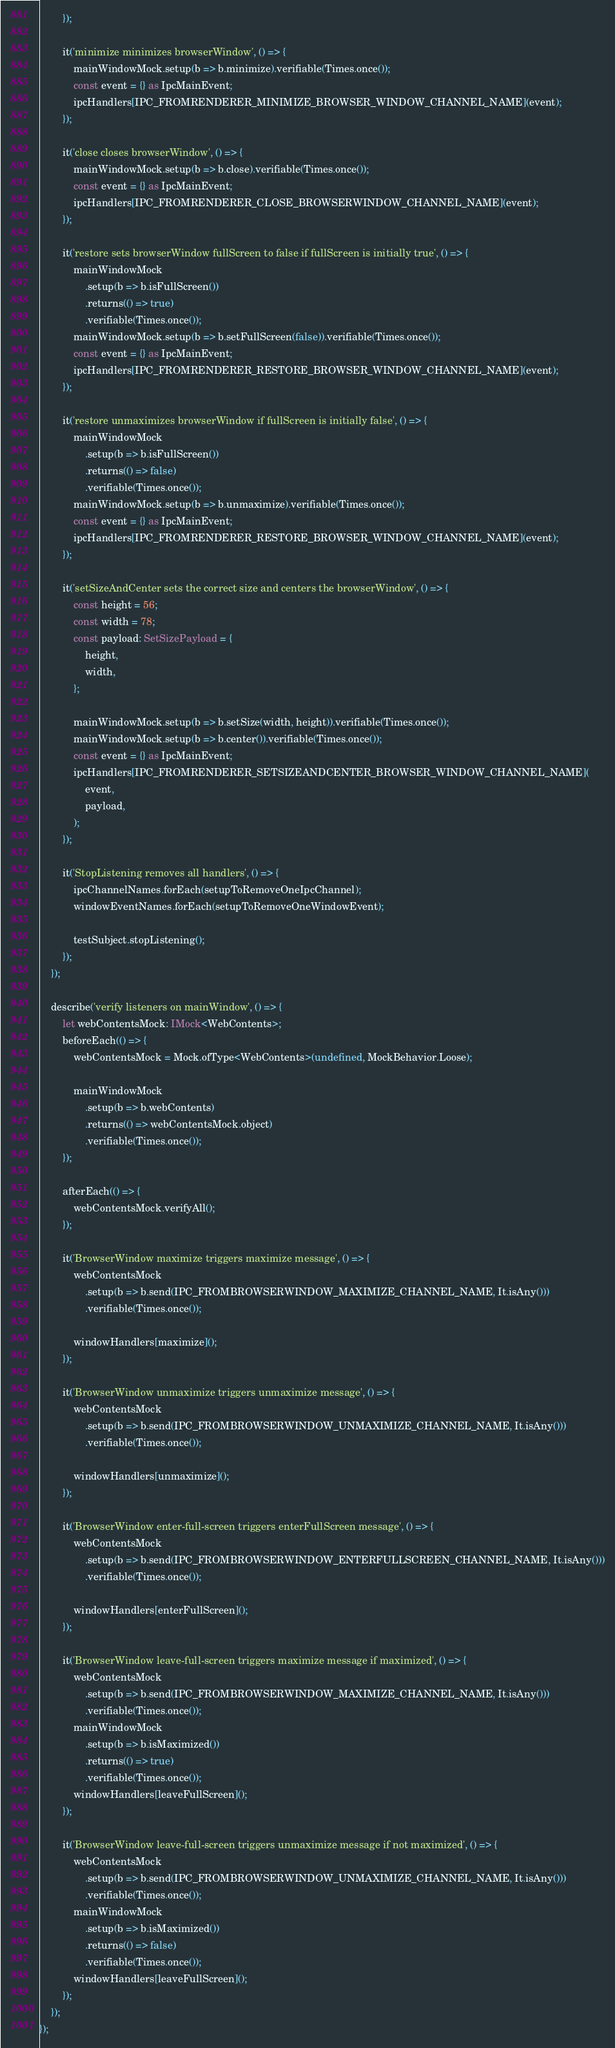Convert code to text. <code><loc_0><loc_0><loc_500><loc_500><_TypeScript_>        });

        it('minimize minimizes browserWindow', () => {
            mainWindowMock.setup(b => b.minimize).verifiable(Times.once());
            const event = {} as IpcMainEvent;
            ipcHandlers[IPC_FROMRENDERER_MINIMIZE_BROWSER_WINDOW_CHANNEL_NAME](event);
        });

        it('close closes browserWindow', () => {
            mainWindowMock.setup(b => b.close).verifiable(Times.once());
            const event = {} as IpcMainEvent;
            ipcHandlers[IPC_FROMRENDERER_CLOSE_BROWSERWINDOW_CHANNEL_NAME](event);
        });

        it('restore sets browserWindow fullScreen to false if fullScreen is initially true', () => {
            mainWindowMock
                .setup(b => b.isFullScreen())
                .returns(() => true)
                .verifiable(Times.once());
            mainWindowMock.setup(b => b.setFullScreen(false)).verifiable(Times.once());
            const event = {} as IpcMainEvent;
            ipcHandlers[IPC_FROMRENDERER_RESTORE_BROWSER_WINDOW_CHANNEL_NAME](event);
        });

        it('restore unmaximizes browserWindow if fullScreen is initially false', () => {
            mainWindowMock
                .setup(b => b.isFullScreen())
                .returns(() => false)
                .verifiable(Times.once());
            mainWindowMock.setup(b => b.unmaximize).verifiable(Times.once());
            const event = {} as IpcMainEvent;
            ipcHandlers[IPC_FROMRENDERER_RESTORE_BROWSER_WINDOW_CHANNEL_NAME](event);
        });

        it('setSizeAndCenter sets the correct size and centers the browserWindow', () => {
            const height = 56;
            const width = 78;
            const payload: SetSizePayload = {
                height,
                width,
            };

            mainWindowMock.setup(b => b.setSize(width, height)).verifiable(Times.once());
            mainWindowMock.setup(b => b.center()).verifiable(Times.once());
            const event = {} as IpcMainEvent;
            ipcHandlers[IPC_FROMRENDERER_SETSIZEANDCENTER_BROWSER_WINDOW_CHANNEL_NAME](
                event,
                payload,
            );
        });

        it('StopListening removes all handlers', () => {
            ipcChannelNames.forEach(setupToRemoveOneIpcChannel);
            windowEventNames.forEach(setupToRemoveOneWindowEvent);

            testSubject.stopListening();
        });
    });

    describe('verify listeners on mainWindow', () => {
        let webContentsMock: IMock<WebContents>;
        beforeEach(() => {
            webContentsMock = Mock.ofType<WebContents>(undefined, MockBehavior.Loose);

            mainWindowMock
                .setup(b => b.webContents)
                .returns(() => webContentsMock.object)
                .verifiable(Times.once());
        });

        afterEach(() => {
            webContentsMock.verifyAll();
        });

        it('BrowserWindow maximize triggers maximize message', () => {
            webContentsMock
                .setup(b => b.send(IPC_FROMBROWSERWINDOW_MAXIMIZE_CHANNEL_NAME, It.isAny()))
                .verifiable(Times.once());

            windowHandlers[maximize]();
        });

        it('BrowserWindow unmaximize triggers unmaximize message', () => {
            webContentsMock
                .setup(b => b.send(IPC_FROMBROWSERWINDOW_UNMAXIMIZE_CHANNEL_NAME, It.isAny()))
                .verifiable(Times.once());

            windowHandlers[unmaximize]();
        });

        it('BrowserWindow enter-full-screen triggers enterFullScreen message', () => {
            webContentsMock
                .setup(b => b.send(IPC_FROMBROWSERWINDOW_ENTERFULLSCREEN_CHANNEL_NAME, It.isAny()))
                .verifiable(Times.once());

            windowHandlers[enterFullScreen]();
        });

        it('BrowserWindow leave-full-screen triggers maximize message if maximized', () => {
            webContentsMock
                .setup(b => b.send(IPC_FROMBROWSERWINDOW_MAXIMIZE_CHANNEL_NAME, It.isAny()))
                .verifiable(Times.once());
            mainWindowMock
                .setup(b => b.isMaximized())
                .returns(() => true)
                .verifiable(Times.once());
            windowHandlers[leaveFullScreen]();
        });

        it('BrowserWindow leave-full-screen triggers unmaximize message if not maximized', () => {
            webContentsMock
                .setup(b => b.send(IPC_FROMBROWSERWINDOW_UNMAXIMIZE_CHANNEL_NAME, It.isAny()))
                .verifiable(Times.once());
            mainWindowMock
                .setup(b => b.isMaximized())
                .returns(() => false)
                .verifiable(Times.once());
            windowHandlers[leaveFullScreen]();
        });
    });
});
</code> 